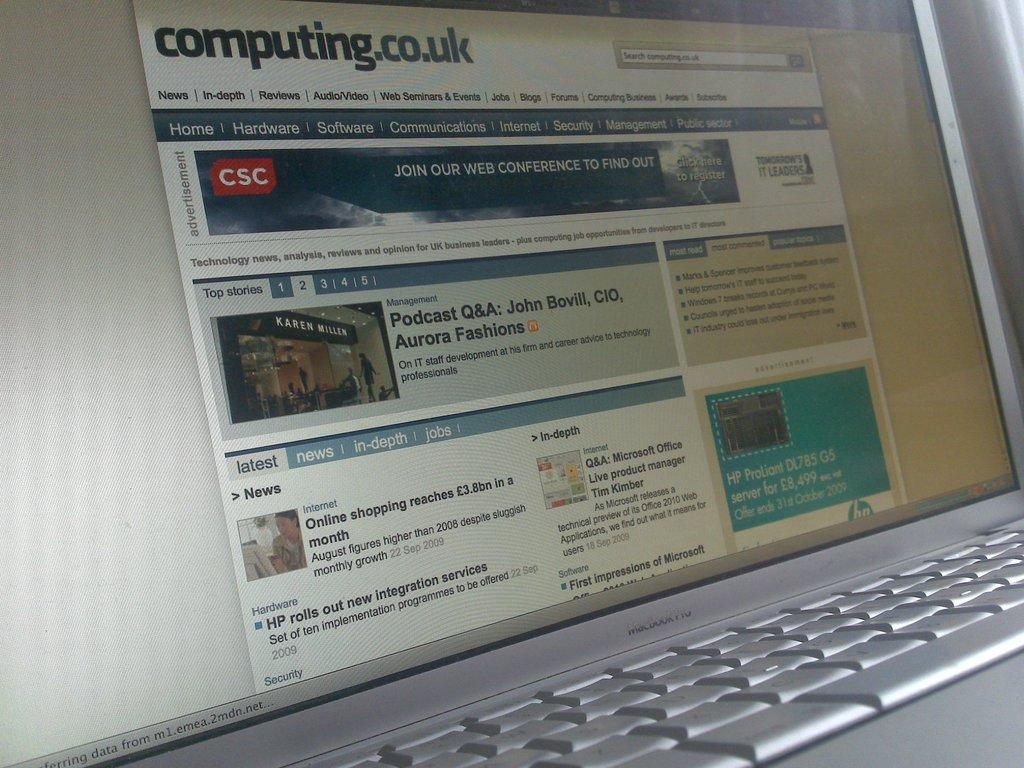<image>
Write a terse but informative summary of the picture. The computer screen is opend to the website computing.co.uk. 